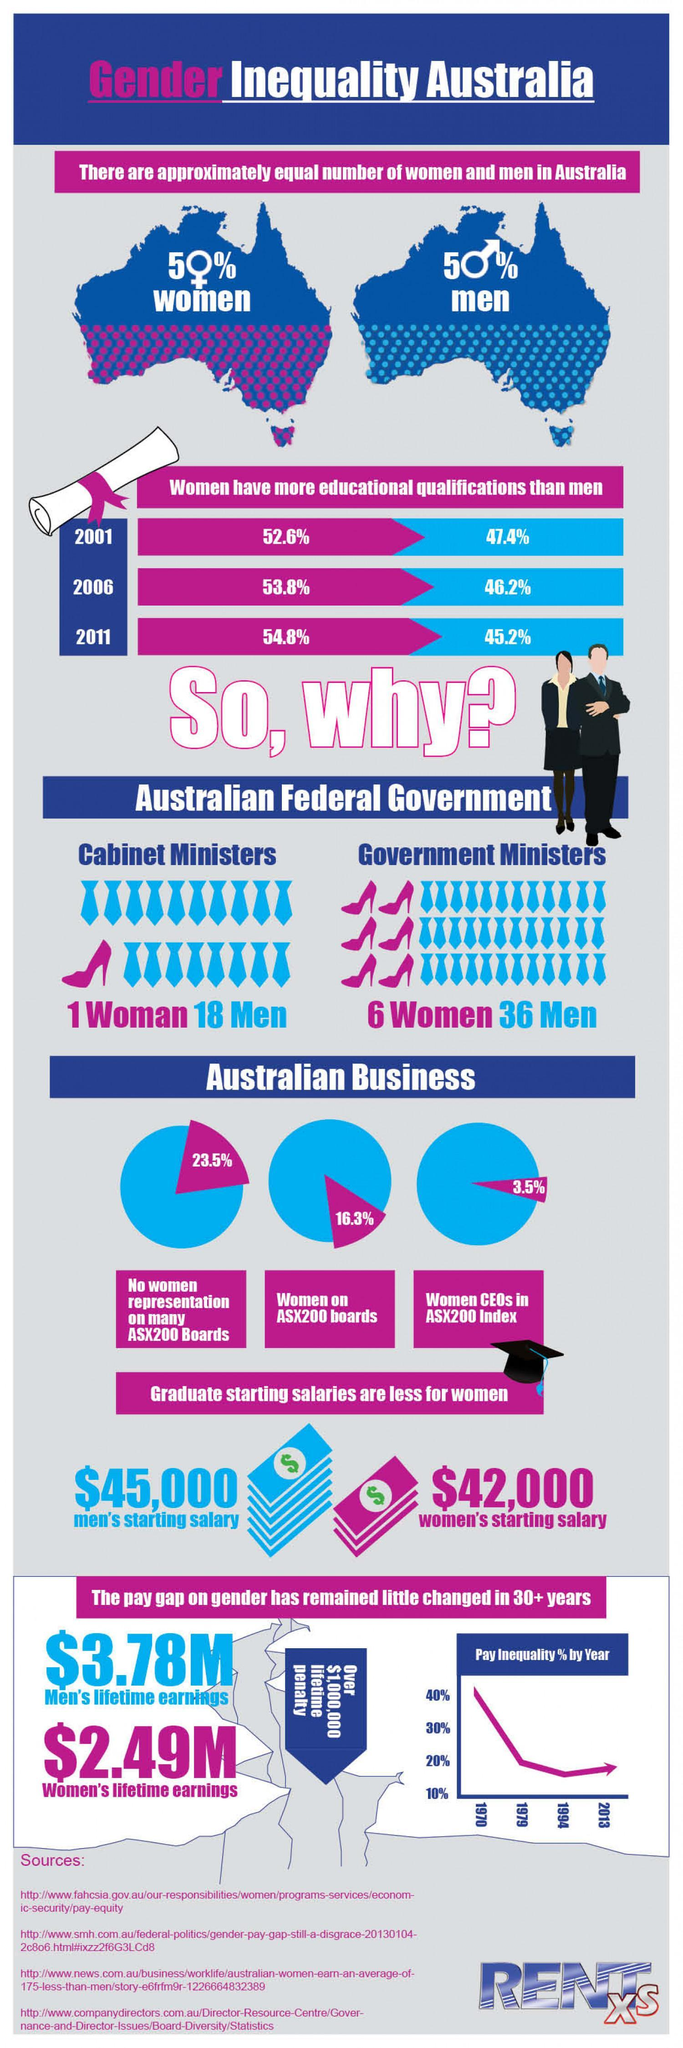What is men's starting salary?
Answer the question with a short phrase. $45,000 What is women's starting salary? $42,000 